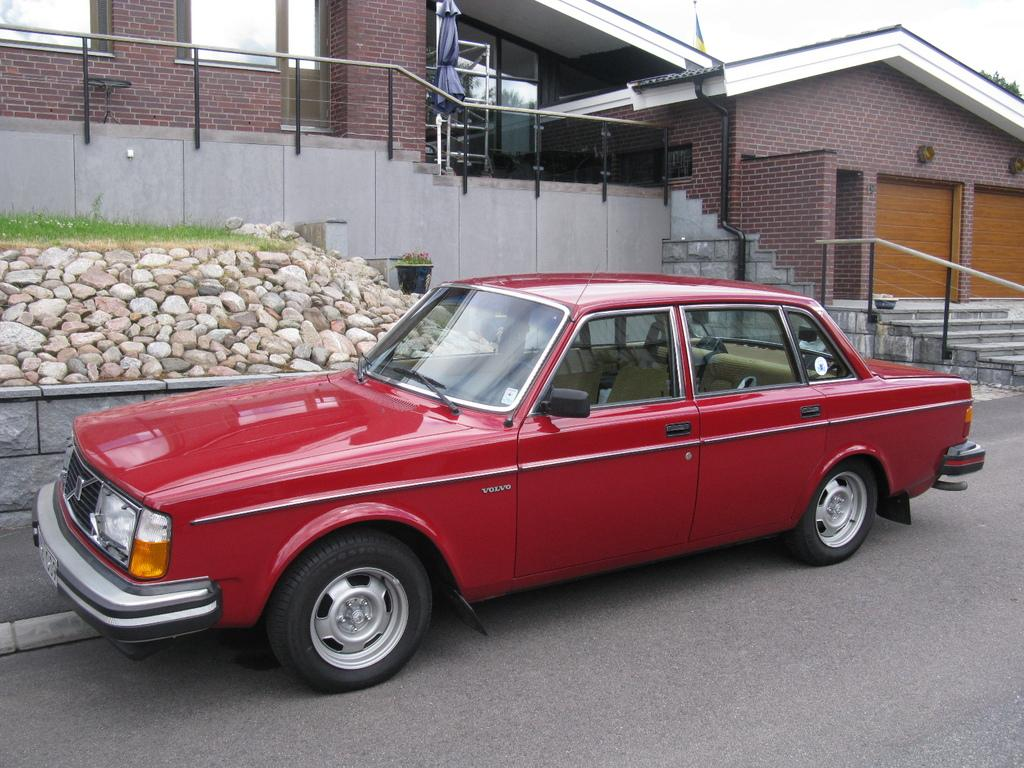What is the main subject of the image? There is a vehicle on the road. What can be seen in the background of the image? In the background, there is a house, rods, steps, a flag, an umbrella, a pipe, rocks, grass, a plant, and a tree. Can you describe the objects in the background? The background features a house, rods, steps, a flag, an umbrella, a pipe, rocks, grass, a plant, and a tree. How many legs can be seen on the vehicle in the image? Vehicles do not have legs; they have wheels. In this image, the vehicle has wheels, not legs. What type of behavior is exhibited by the plant in the image? Plants do not exhibit behavior; they are stationary organisms. In this image, the plant is simply present in the background. 